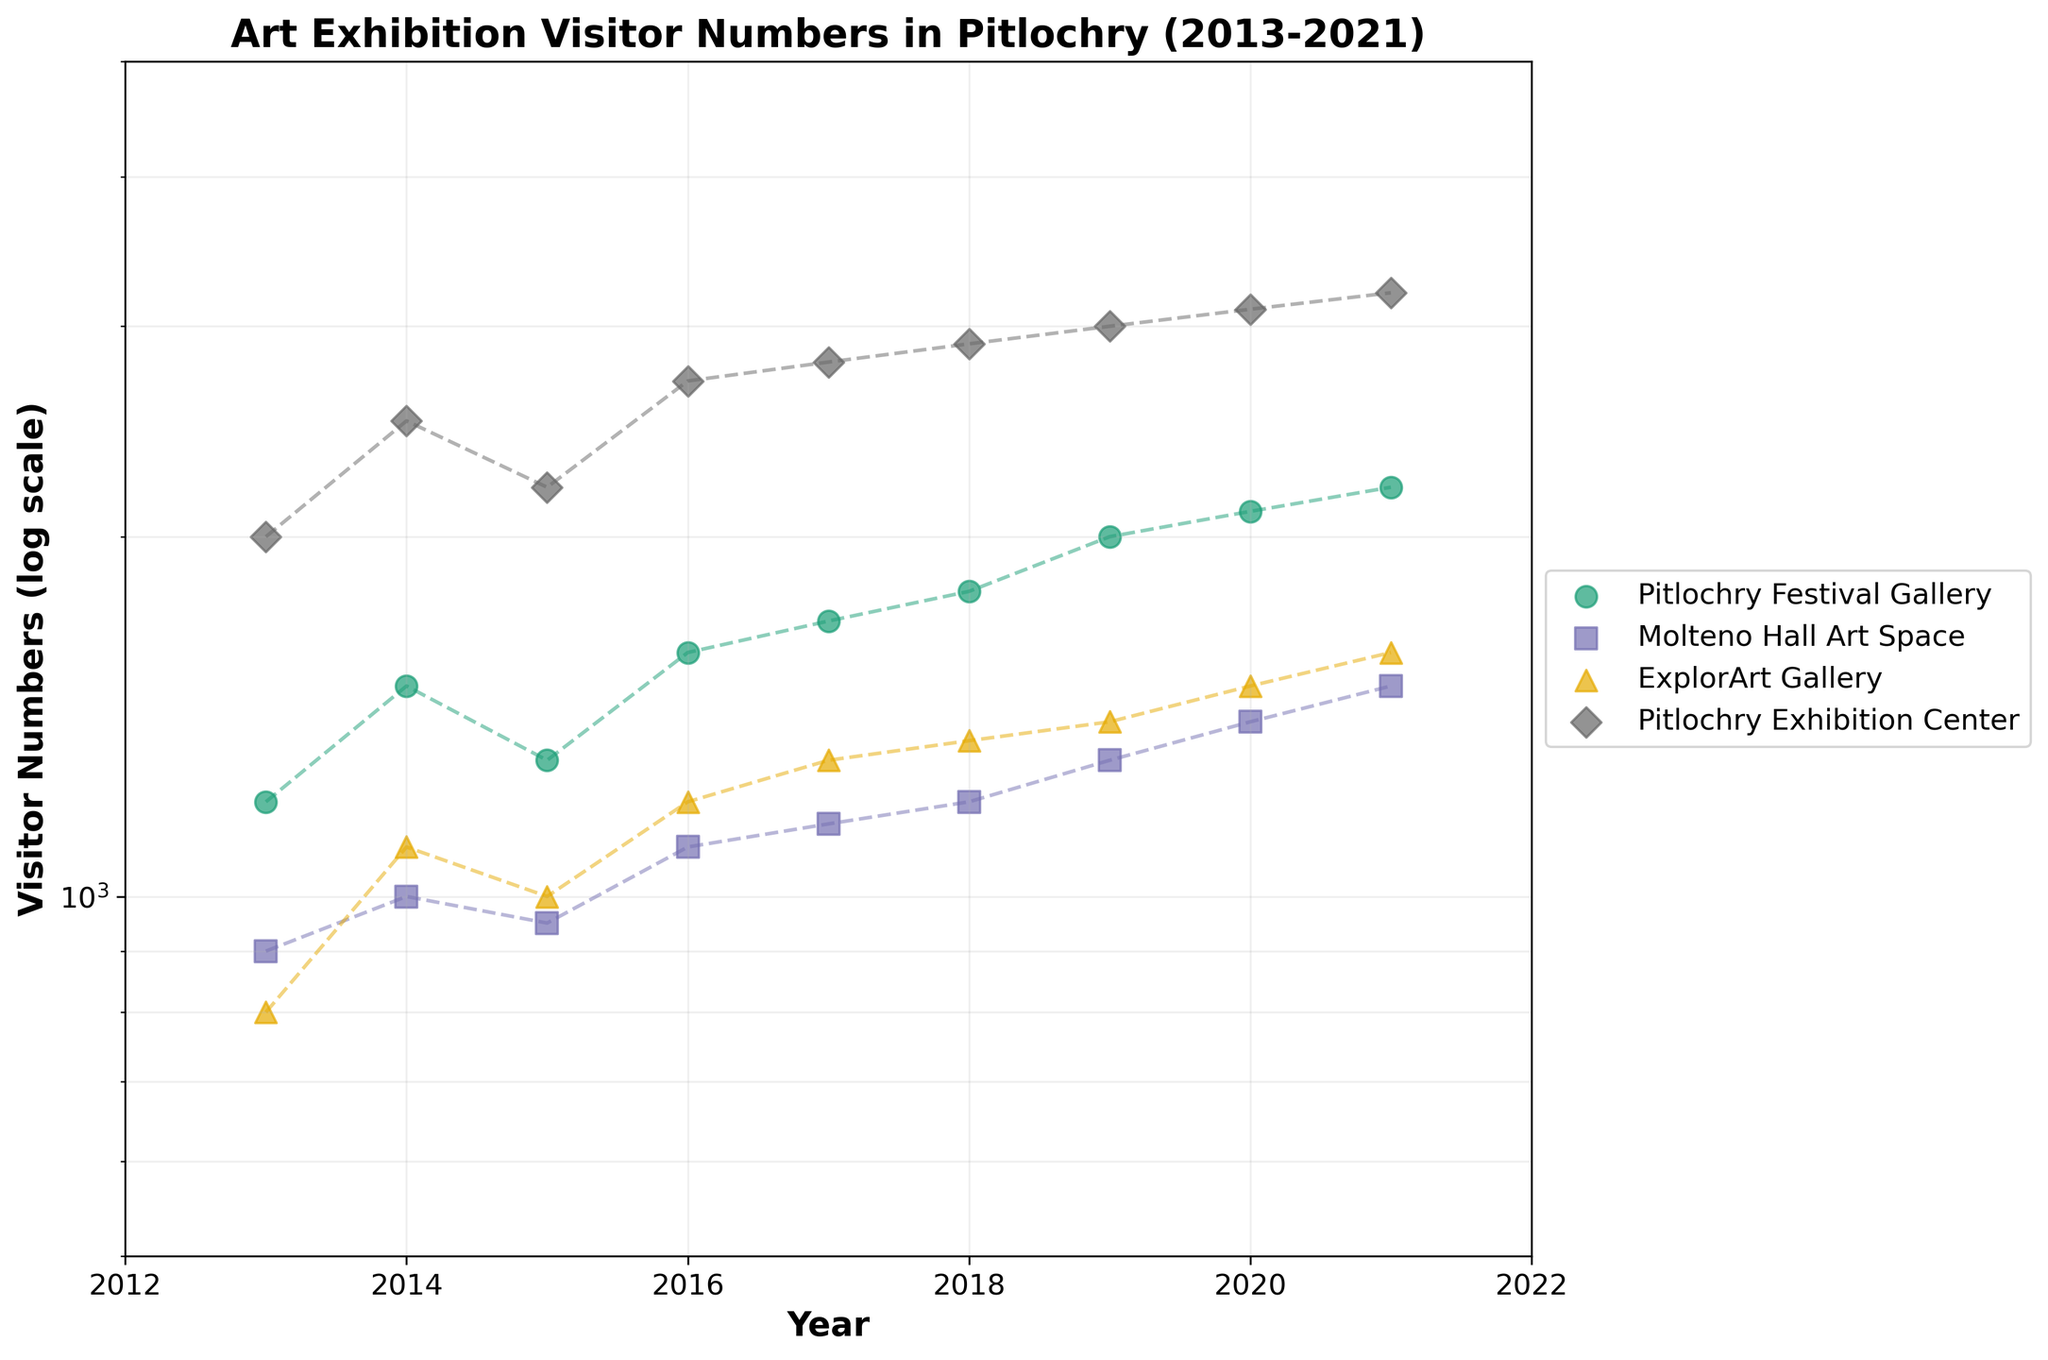What is the title of the graph? The title of the graph is located at the top of the figure. It provides a brief description of the graph's content. The title is "Art Exhibition Visitor Numbers in Pitlochry (2013-2021)"
Answer: Art Exhibition Visitor Numbers in Pitlochry (2013-2021) How many exhibitions' data are represented in the plot? There are unique markers and colors for each exhibition on the plot. By counting the number of unique legends, we can determine the number of exhibitions. There are 4 exhibitions.
Answer: 4 Between 2013 and 2021, which year had the highest visitor numbers for any exhibition? To answer this, observe the peak value along the y-axis, which is on a log scale, and note the corresponding year along the x-axis. The peak is at 3200 visitors for Pitlochry Exhibition Center in 2021.
Answer: 2021 Comparing Pitlochry Festival Gallery and Molteno Hall Art Space, which had more visitors in 2015? Locate the points for both exhibitions in 2015 on the graph and compare their positions on the y-axis. Pitlochry Festival Gallery had around 1300 visitors while Molteno Hall Art Space had around 950.
Answer: Pitlochry Festival Gallery What was the trend of visitor numbers for ExplorArt Gallery from 2013 to 2021? To determine the trend, follow the line plot for ExplorArt Gallery from 2013 to 2021. The trend shows a steady increase in visitor numbers from 800 in 2013 to 1600 in 2021.
Answer: Steady increase What is the difference in visitor numbers between Pitlochry Exhibition Center and ExplorArt Gallery in 2020? Find the visitor numbers for both exhibitions in 2020 and subtract the smaller number from the larger one. Pitlochry Exhibition Center had 3100 visitors, and ExplorArt Gallery had 1500 visitors. The difference is 3100 - 1500 = 1600.
Answer: 1600 In which year did Molteno Hall Art Space have the highest visitor numbers, and what was the count? Check the trend line for Molteno Hall Art Space and find the peak value along the y-axis. The highest visitor numbers were in 2021, with 1500 visitors.
Answer: 2021, 1500 How do visitor numbers in 2013 compare among all exhibitions? Compare the visitor numbers for each exhibition in 2013 by looking at the y-axis values for each marker in that year. Pitlochry Exhibition Center had the most with 2000 visitors, followed by Pitlochry Festival Gallery with 1200, Molteno Hall Art Space with 900, and ExplorArt Gallery with 800.
Answer: Pitlochry Exhibition Center > Pitlochry Festival Gallery > Molteno Hall Art Space > ExplorArt Gallery Which exhibition had a consistent increase in visitors every year from 2016 to 2021? Examine each exhibition's trend line from 2016 to 2021 and identify which line consistently rises without any decline. Molteno Hall Art Space shows a consistent increase each year from 1100 in 2016 to 1500 in 2021.
Answer: Molteno Hall Art Space By how much did the visitor numbers for Pitlochry Festival Gallery increase from 2018 to 2019? Find the visitor numbers for 2018 and 2019 for Pitlochry Festival Gallery and calculate the difference. In 2018, there were 1800 visitors, and in 2019, there were 2000. The increase is 2000 - 1800 = 200.
Answer: 200 